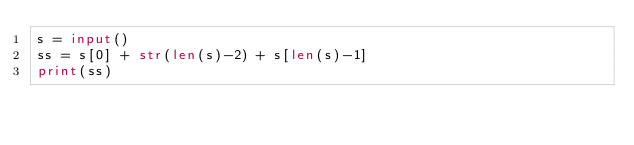Convert code to text. <code><loc_0><loc_0><loc_500><loc_500><_Python_>s = input()
ss = s[0] + str(len(s)-2) + s[len(s)-1]
print(ss)</code> 